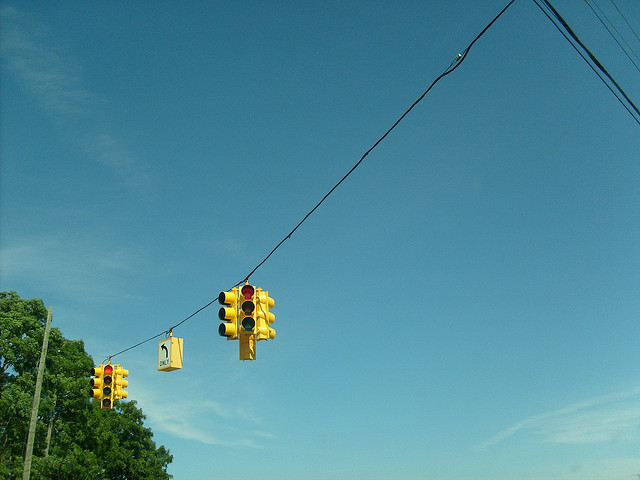<image>Why are there so many lights? I don't know why there are so many lights. It could be due to traffic, multiple intersections or to direct traffic. Why are there so many lights? I don't know why there are so many lights. It could be because of multiple intersections, traffic signals, or to direct traffic. 